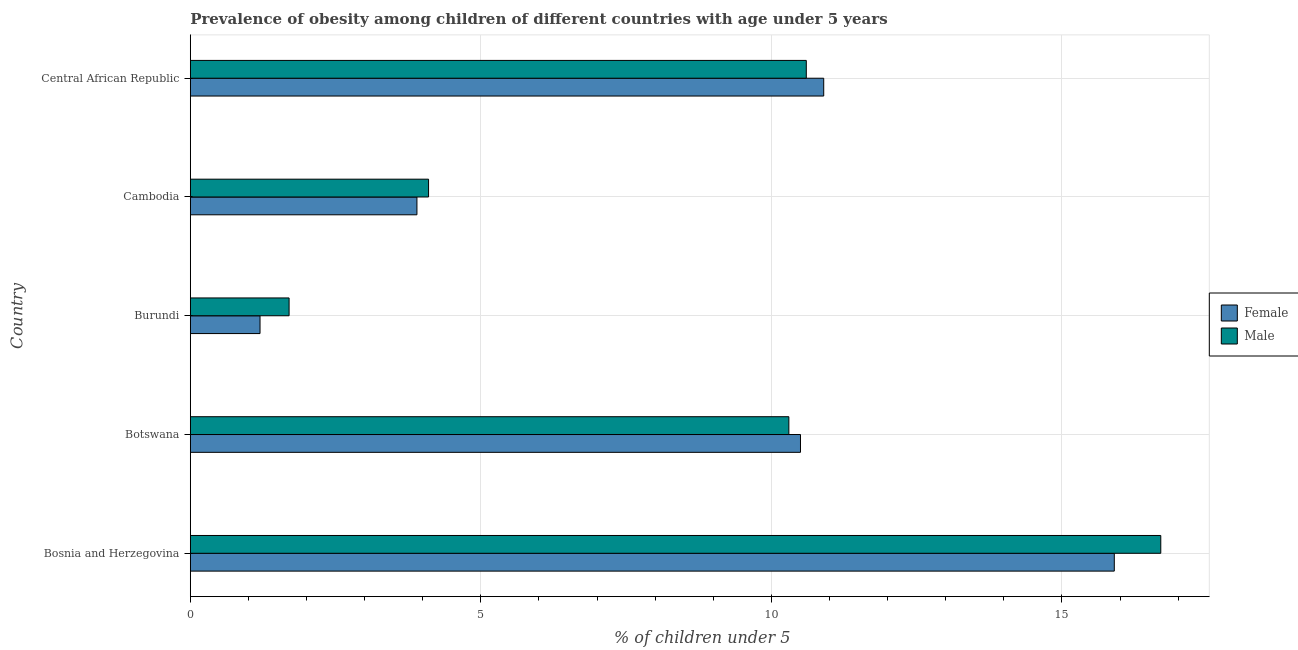How many different coloured bars are there?
Your answer should be very brief. 2. How many groups of bars are there?
Ensure brevity in your answer.  5. Are the number of bars per tick equal to the number of legend labels?
Offer a very short reply. Yes. How many bars are there on the 3rd tick from the top?
Give a very brief answer. 2. How many bars are there on the 3rd tick from the bottom?
Give a very brief answer. 2. What is the label of the 1st group of bars from the top?
Provide a short and direct response. Central African Republic. What is the percentage of obese female children in Burundi?
Offer a very short reply. 1.2. Across all countries, what is the maximum percentage of obese male children?
Your answer should be very brief. 16.7. Across all countries, what is the minimum percentage of obese male children?
Make the answer very short. 1.7. In which country was the percentage of obese male children maximum?
Offer a terse response. Bosnia and Herzegovina. In which country was the percentage of obese female children minimum?
Give a very brief answer. Burundi. What is the total percentage of obese female children in the graph?
Offer a terse response. 42.4. What is the difference between the percentage of obese female children in Botswana and the percentage of obese male children in Bosnia and Herzegovina?
Give a very brief answer. -6.2. What is the average percentage of obese male children per country?
Offer a very short reply. 8.68. What is the difference between the percentage of obese female children and percentage of obese male children in Botswana?
Keep it short and to the point. 0.2. What is the ratio of the percentage of obese female children in Cambodia to that in Central African Republic?
Ensure brevity in your answer.  0.36. Is the percentage of obese male children in Burundi less than that in Cambodia?
Provide a succinct answer. Yes. What is the difference between the highest and the second highest percentage of obese male children?
Offer a terse response. 6.1. In how many countries, is the percentage of obese male children greater than the average percentage of obese male children taken over all countries?
Provide a succinct answer. 3. How many countries are there in the graph?
Make the answer very short. 5. What is the difference between two consecutive major ticks on the X-axis?
Provide a succinct answer. 5. Are the values on the major ticks of X-axis written in scientific E-notation?
Your answer should be compact. No. Does the graph contain any zero values?
Your answer should be very brief. No. Where does the legend appear in the graph?
Keep it short and to the point. Center right. How many legend labels are there?
Give a very brief answer. 2. How are the legend labels stacked?
Keep it short and to the point. Vertical. What is the title of the graph?
Make the answer very short. Prevalence of obesity among children of different countries with age under 5 years. Does "Urban agglomerations" appear as one of the legend labels in the graph?
Your response must be concise. No. What is the label or title of the X-axis?
Offer a terse response.  % of children under 5. What is the label or title of the Y-axis?
Ensure brevity in your answer.  Country. What is the  % of children under 5 in Female in Bosnia and Herzegovina?
Keep it short and to the point. 15.9. What is the  % of children under 5 in Male in Bosnia and Herzegovina?
Provide a short and direct response. 16.7. What is the  % of children under 5 of Male in Botswana?
Your answer should be very brief. 10.3. What is the  % of children under 5 of Female in Burundi?
Give a very brief answer. 1.2. What is the  % of children under 5 in Male in Burundi?
Ensure brevity in your answer.  1.7. What is the  % of children under 5 in Female in Cambodia?
Ensure brevity in your answer.  3.9. What is the  % of children under 5 in Male in Cambodia?
Give a very brief answer. 4.1. What is the  % of children under 5 in Female in Central African Republic?
Make the answer very short. 10.9. What is the  % of children under 5 of Male in Central African Republic?
Your answer should be compact. 10.6. Across all countries, what is the maximum  % of children under 5 in Female?
Offer a terse response. 15.9. Across all countries, what is the maximum  % of children under 5 of Male?
Your response must be concise. 16.7. Across all countries, what is the minimum  % of children under 5 of Female?
Ensure brevity in your answer.  1.2. Across all countries, what is the minimum  % of children under 5 of Male?
Your answer should be compact. 1.7. What is the total  % of children under 5 of Female in the graph?
Your answer should be very brief. 42.4. What is the total  % of children under 5 in Male in the graph?
Keep it short and to the point. 43.4. What is the difference between the  % of children under 5 of Male in Bosnia and Herzegovina and that in Cambodia?
Offer a terse response. 12.6. What is the difference between the  % of children under 5 in Female in Bosnia and Herzegovina and that in Central African Republic?
Give a very brief answer. 5. What is the difference between the  % of children under 5 in Male in Bosnia and Herzegovina and that in Central African Republic?
Ensure brevity in your answer.  6.1. What is the difference between the  % of children under 5 in Female in Botswana and that in Burundi?
Provide a succinct answer. 9.3. What is the difference between the  % of children under 5 of Male in Botswana and that in Burundi?
Provide a succinct answer. 8.6. What is the difference between the  % of children under 5 in Female in Bosnia and Herzegovina and the  % of children under 5 in Male in Botswana?
Offer a terse response. 5.6. What is the difference between the  % of children under 5 of Female in Bosnia and Herzegovina and the  % of children under 5 of Male in Cambodia?
Provide a succinct answer. 11.8. What is the difference between the  % of children under 5 of Female in Botswana and the  % of children under 5 of Male in Cambodia?
Ensure brevity in your answer.  6.4. What is the difference between the  % of children under 5 of Female in Botswana and the  % of children under 5 of Male in Central African Republic?
Make the answer very short. -0.1. What is the difference between the  % of children under 5 of Female in Burundi and the  % of children under 5 of Male in Central African Republic?
Your answer should be compact. -9.4. What is the difference between the  % of children under 5 of Female in Cambodia and the  % of children under 5 of Male in Central African Republic?
Keep it short and to the point. -6.7. What is the average  % of children under 5 of Female per country?
Provide a succinct answer. 8.48. What is the average  % of children under 5 in Male per country?
Your answer should be very brief. 8.68. What is the difference between the  % of children under 5 in Female and  % of children under 5 in Male in Bosnia and Herzegovina?
Provide a short and direct response. -0.8. What is the difference between the  % of children under 5 of Female and  % of children under 5 of Male in Botswana?
Provide a succinct answer. 0.2. What is the difference between the  % of children under 5 of Female and  % of children under 5 of Male in Burundi?
Ensure brevity in your answer.  -0.5. What is the ratio of the  % of children under 5 of Female in Bosnia and Herzegovina to that in Botswana?
Give a very brief answer. 1.51. What is the ratio of the  % of children under 5 in Male in Bosnia and Herzegovina to that in Botswana?
Your response must be concise. 1.62. What is the ratio of the  % of children under 5 of Female in Bosnia and Herzegovina to that in Burundi?
Your response must be concise. 13.25. What is the ratio of the  % of children under 5 in Male in Bosnia and Herzegovina to that in Burundi?
Keep it short and to the point. 9.82. What is the ratio of the  % of children under 5 in Female in Bosnia and Herzegovina to that in Cambodia?
Offer a very short reply. 4.08. What is the ratio of the  % of children under 5 of Male in Bosnia and Herzegovina to that in Cambodia?
Provide a succinct answer. 4.07. What is the ratio of the  % of children under 5 in Female in Bosnia and Herzegovina to that in Central African Republic?
Give a very brief answer. 1.46. What is the ratio of the  % of children under 5 in Male in Bosnia and Herzegovina to that in Central African Republic?
Provide a short and direct response. 1.58. What is the ratio of the  % of children under 5 of Female in Botswana to that in Burundi?
Offer a terse response. 8.75. What is the ratio of the  % of children under 5 of Male in Botswana to that in Burundi?
Give a very brief answer. 6.06. What is the ratio of the  % of children under 5 of Female in Botswana to that in Cambodia?
Your answer should be very brief. 2.69. What is the ratio of the  % of children under 5 of Male in Botswana to that in Cambodia?
Provide a succinct answer. 2.51. What is the ratio of the  % of children under 5 of Female in Botswana to that in Central African Republic?
Your answer should be compact. 0.96. What is the ratio of the  % of children under 5 in Male in Botswana to that in Central African Republic?
Give a very brief answer. 0.97. What is the ratio of the  % of children under 5 in Female in Burundi to that in Cambodia?
Offer a very short reply. 0.31. What is the ratio of the  % of children under 5 of Male in Burundi to that in Cambodia?
Offer a terse response. 0.41. What is the ratio of the  % of children under 5 in Female in Burundi to that in Central African Republic?
Provide a succinct answer. 0.11. What is the ratio of the  % of children under 5 of Male in Burundi to that in Central African Republic?
Provide a short and direct response. 0.16. What is the ratio of the  % of children under 5 in Female in Cambodia to that in Central African Republic?
Your answer should be compact. 0.36. What is the ratio of the  % of children under 5 of Male in Cambodia to that in Central African Republic?
Offer a terse response. 0.39. What is the difference between the highest and the second highest  % of children under 5 in Female?
Provide a succinct answer. 5. 